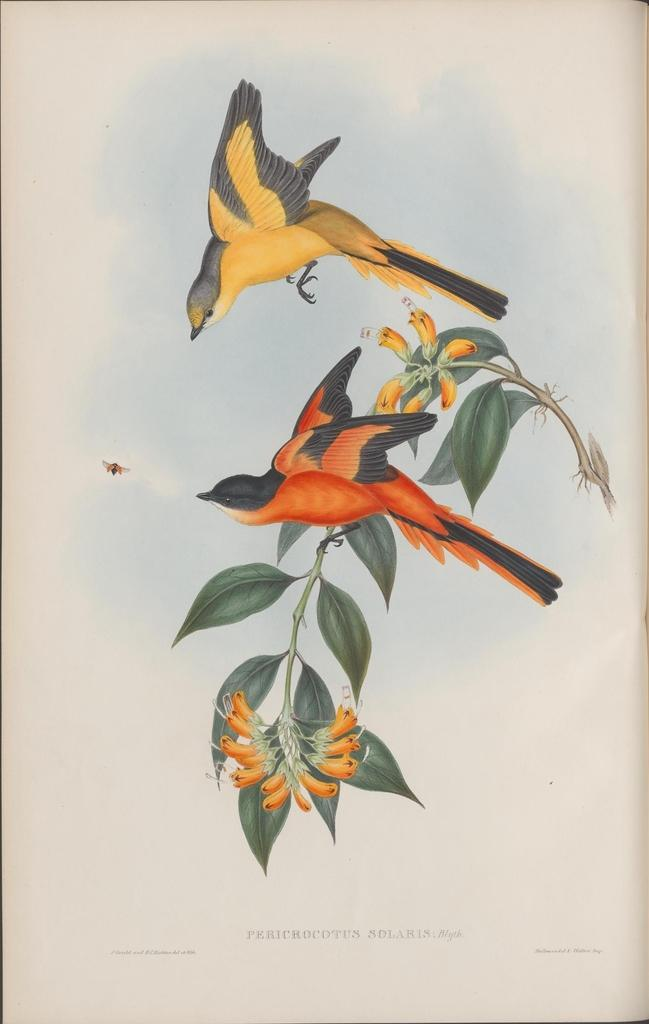What type of image is being described? The image is an animated poster. What can be seen on the plant in the image? There are flowers on the plant, and an orange bird is also on the plant. What is happening with the other bird in the image? Another bird is flying in the air. Can you describe any other elements in the image? There is a fly on the left side of the image. What type of thrill can be seen on the bird's face as it looks at the vase? There is no vase present in the image, and the bird's face cannot be seen, so it is not possible to determine any thrill or emotion. 